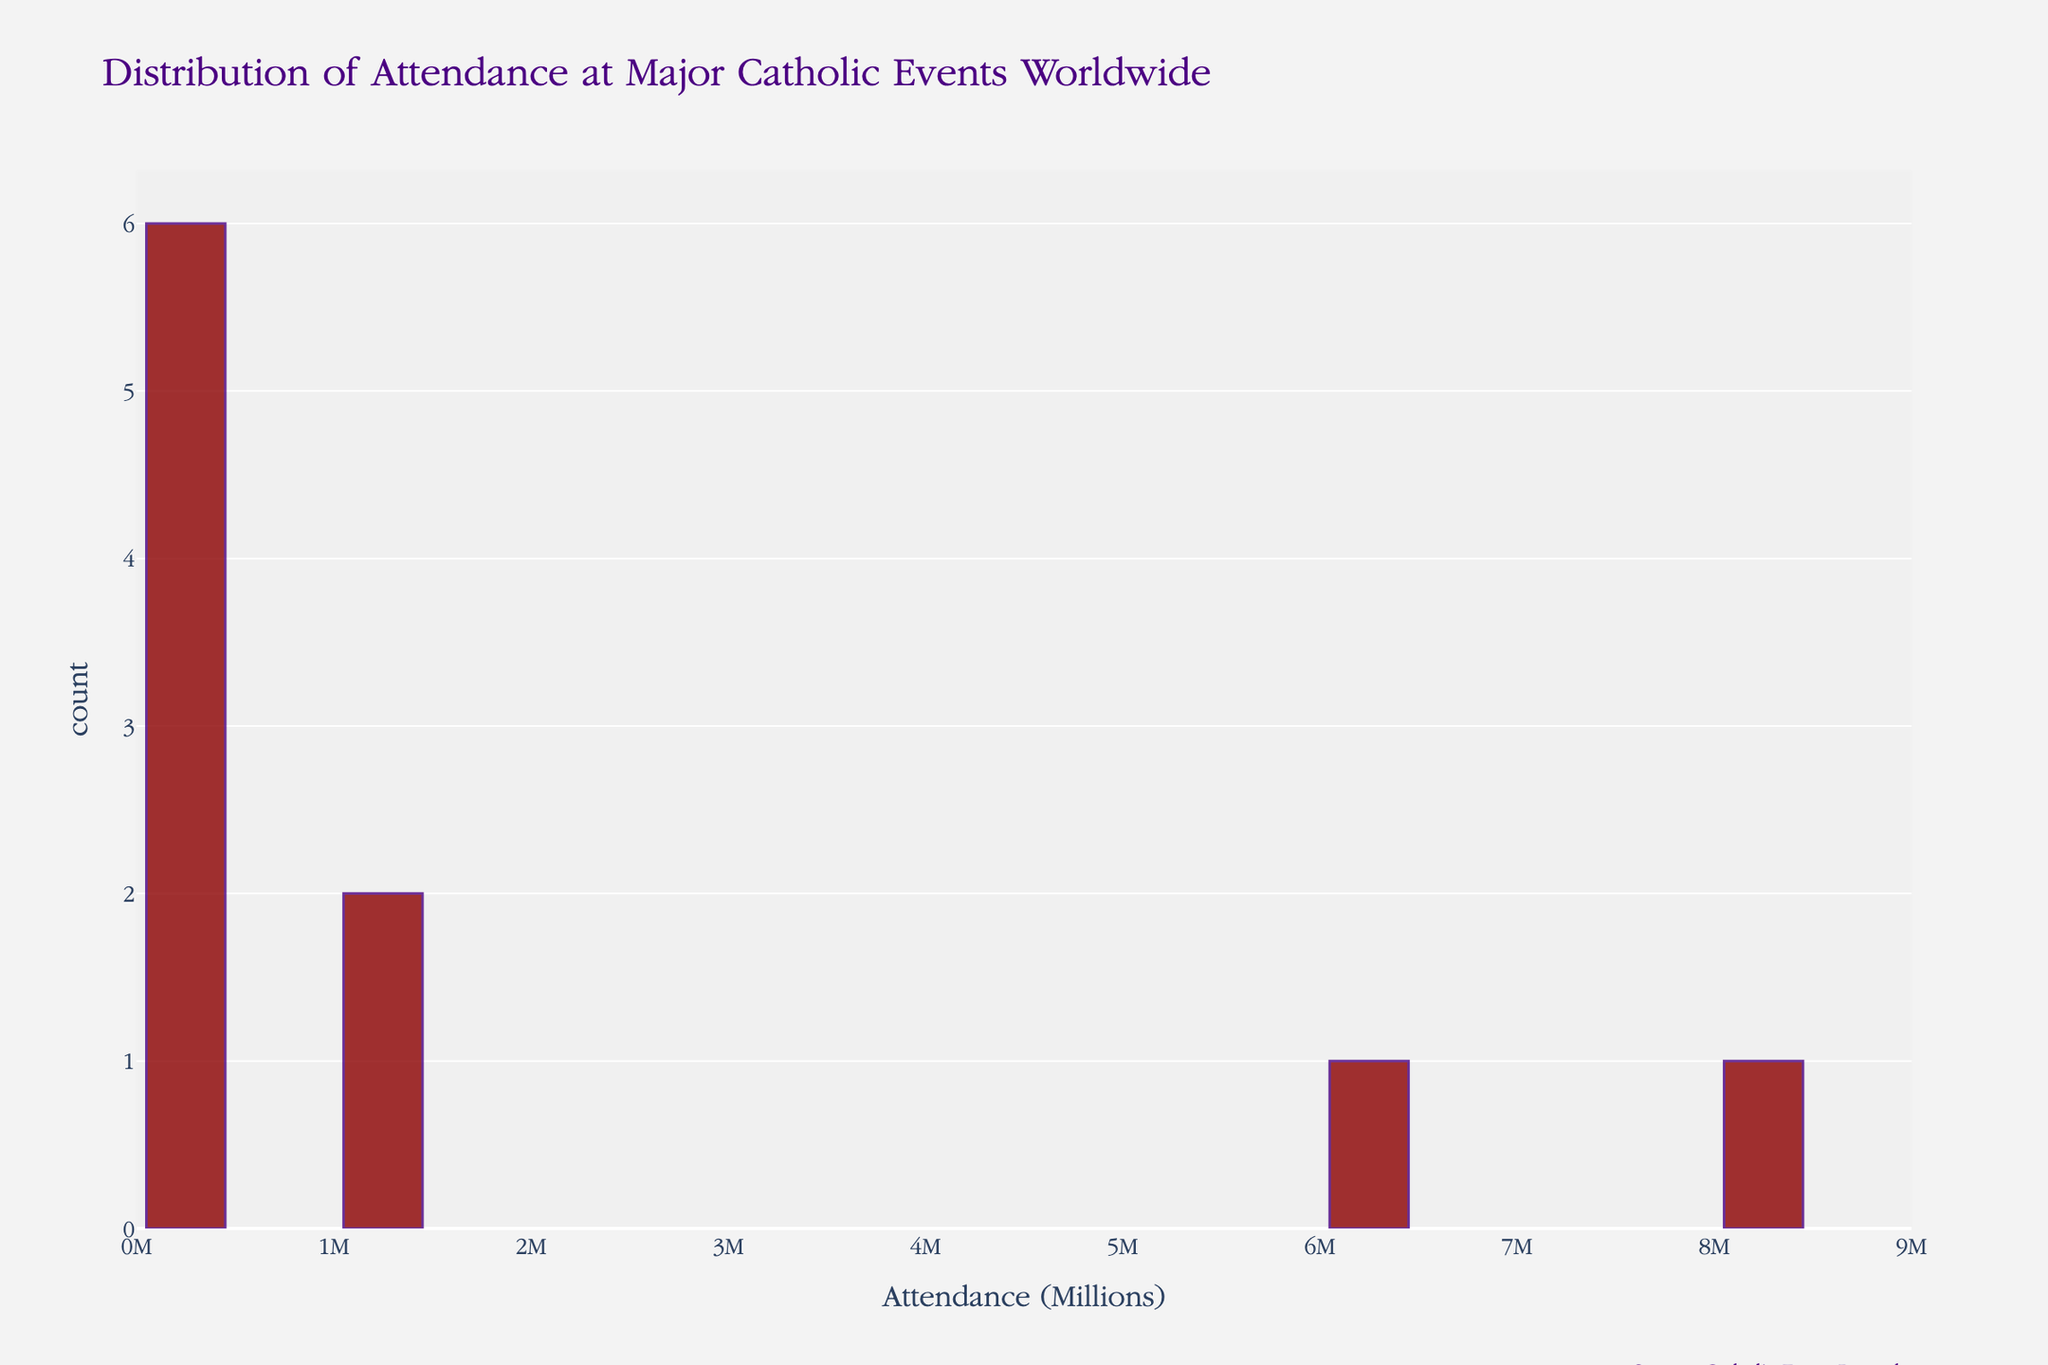What's the title of the histogram? The title of the histogram is displayed at the top and reads "Distribution of Attendance at Major Catholic Events Worldwide".
Answer: Distribution of Attendance at Major Catholic Events Worldwide How many events have an attendance of more than 1 million? Count the number of bars that represent attendance figures greater than 1,000,000. Each of those bars represents one event.
Answer: 4 Which event had the highest attendance? Identify the event with the tallest bar on the histogram, corresponding to the highest attendance number.
Answer: Our Lady of Guadalupe Feast 2022 (Mexico) What's the range of attendance values? The range is determined by identifying the smallest and largest attendance values on the x-axis and then calculating the difference between these two values. The smallest is 50,000, and the largest is 8,000,000.
Answer: 50,000 to 8,000,000 How many bins are there in the histogram? Count the total number of vertical bars (bins) present in the histogram.
Answer: 20 Which event had the lowest attendance? Identify the event with the shortest bar on the histogram, corresponding to the lowest attendance number.
Answer: Easter Mass at St. Peter's Square 2022 Are there more events with attendance below or above 1 million? Count the number of bins with attendance figures below and above 1,000,000 and compare them.
Answer: Below 1 million What is the color of the bars in the histogram? The bars' color is described in the histogram's customization.
Answer: Dark red How many events had attendance between 200,000 and 400,000? Count the number of bars that fall within the 200,000 to 400,000 range on the x-axis.
Answer: 2 What is the median attendance figure based on the histogram? To find the median, list all attendance figures, sort them, and identify the middle value. The attendance numbers are sorted: 50,000, 65,000, 200,000, 250,000, 300,000, 400,000, 1,000,000, 1,200,000, 6,000,000, 8,000,000. The middle value (5th and 6th) is 300,000 and 400,000, so the median is the average of these two: (300,000+400,000)/2 = 350,000.
Answer: 350,000 